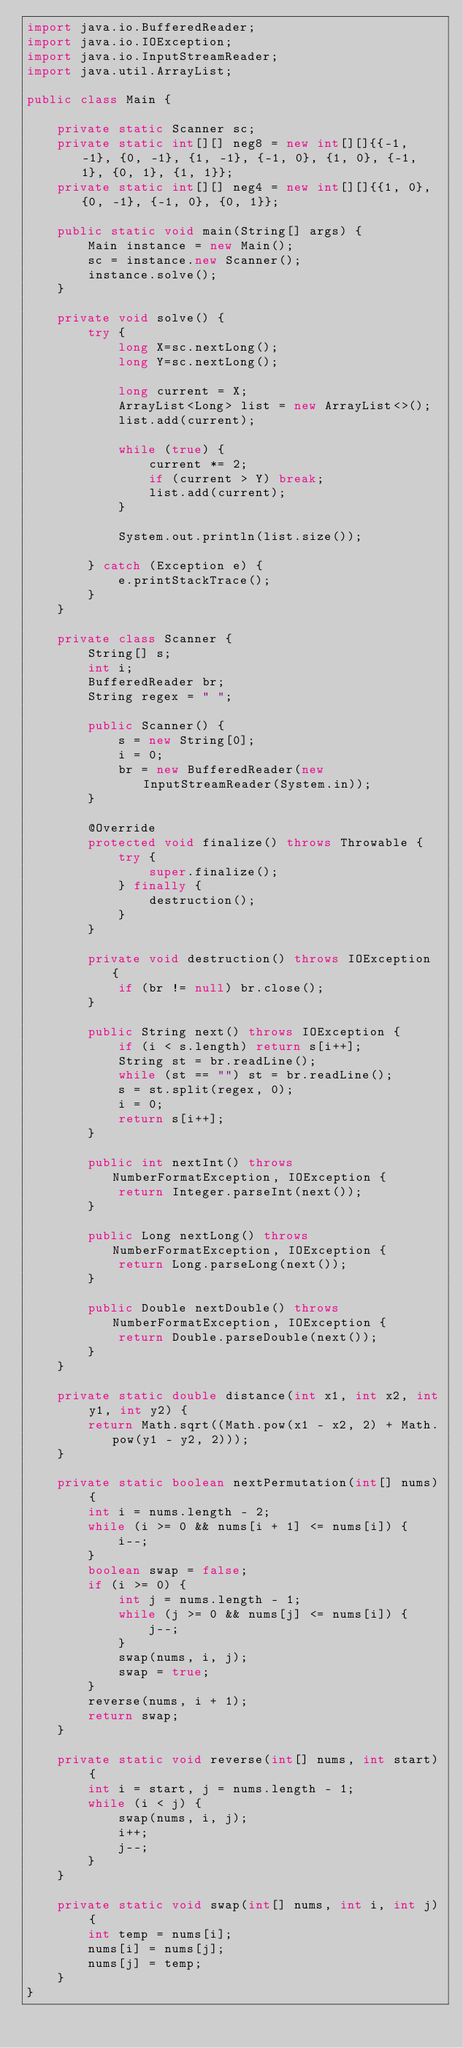<code> <loc_0><loc_0><loc_500><loc_500><_Java_>import java.io.BufferedReader;
import java.io.IOException;
import java.io.InputStreamReader;
import java.util.ArrayList;

public class Main {

    private static Scanner sc;
    private static int[][] neg8 = new int[][]{{-1, -1}, {0, -1}, {1, -1}, {-1, 0}, {1, 0}, {-1, 1}, {0, 1}, {1, 1}};
    private static int[][] neg4 = new int[][]{{1, 0}, {0, -1}, {-1, 0}, {0, 1}};

    public static void main(String[] args) {
        Main instance = new Main();
        sc = instance.new Scanner();
        instance.solve();
    }

    private void solve() {
        try {
            long X=sc.nextLong();
            long Y=sc.nextLong();

            long current = X;
            ArrayList<Long> list = new ArrayList<>();
            list.add(current);

            while (true) {
                current *= 2;
                if (current > Y) break;
                list.add(current);
            }

            System.out.println(list.size());

        } catch (Exception e) {
            e.printStackTrace();
        }
    }

    private class Scanner {
        String[] s;
        int i;
        BufferedReader br;
        String regex = " ";

        public Scanner() {
            s = new String[0];
            i = 0;
            br = new BufferedReader(new InputStreamReader(System.in));
        }

        @Override
        protected void finalize() throws Throwable {
            try {
                super.finalize();
            } finally {
                destruction();
            }
        }

        private void destruction() throws IOException {
            if (br != null) br.close();
        }

        public String next() throws IOException {
            if (i < s.length) return s[i++];
            String st = br.readLine();
            while (st == "") st = br.readLine();
            s = st.split(regex, 0);
            i = 0;
            return s[i++];
        }

        public int nextInt() throws NumberFormatException, IOException {
            return Integer.parseInt(next());
        }

        public Long nextLong() throws NumberFormatException, IOException {
            return Long.parseLong(next());
        }

        public Double nextDouble() throws NumberFormatException, IOException {
            return Double.parseDouble(next());
        }
    }

    private static double distance(int x1, int x2, int y1, int y2) {
        return Math.sqrt((Math.pow(x1 - x2, 2) + Math.pow(y1 - y2, 2)));
    }

    private static boolean nextPermutation(int[] nums) {
        int i = nums.length - 2;
        while (i >= 0 && nums[i + 1] <= nums[i]) {
            i--;
        }
        boolean swap = false;
        if (i >= 0) {
            int j = nums.length - 1;
            while (j >= 0 && nums[j] <= nums[i]) {
                j--;
            }
            swap(nums, i, j);
            swap = true;
        }
        reverse(nums, i + 1);
        return swap;
    }

    private static void reverse(int[] nums, int start) {
        int i = start, j = nums.length - 1;
        while (i < j) {
            swap(nums, i, j);
            i++;
            j--;
        }
    }

    private static void swap(int[] nums, int i, int j) {
        int temp = nums[i];
        nums[i] = nums[j];
        nums[j] = temp;
    }
}

</code> 